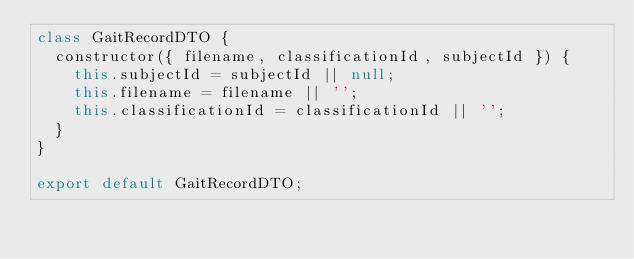<code> <loc_0><loc_0><loc_500><loc_500><_JavaScript_>class GaitRecordDTO {
  constructor({ filename, classificationId, subjectId }) {
    this.subjectId = subjectId || null;
    this.filename = filename || '';
    this.classificationId = classificationId || '';
  }
}

export default GaitRecordDTO;
</code> 